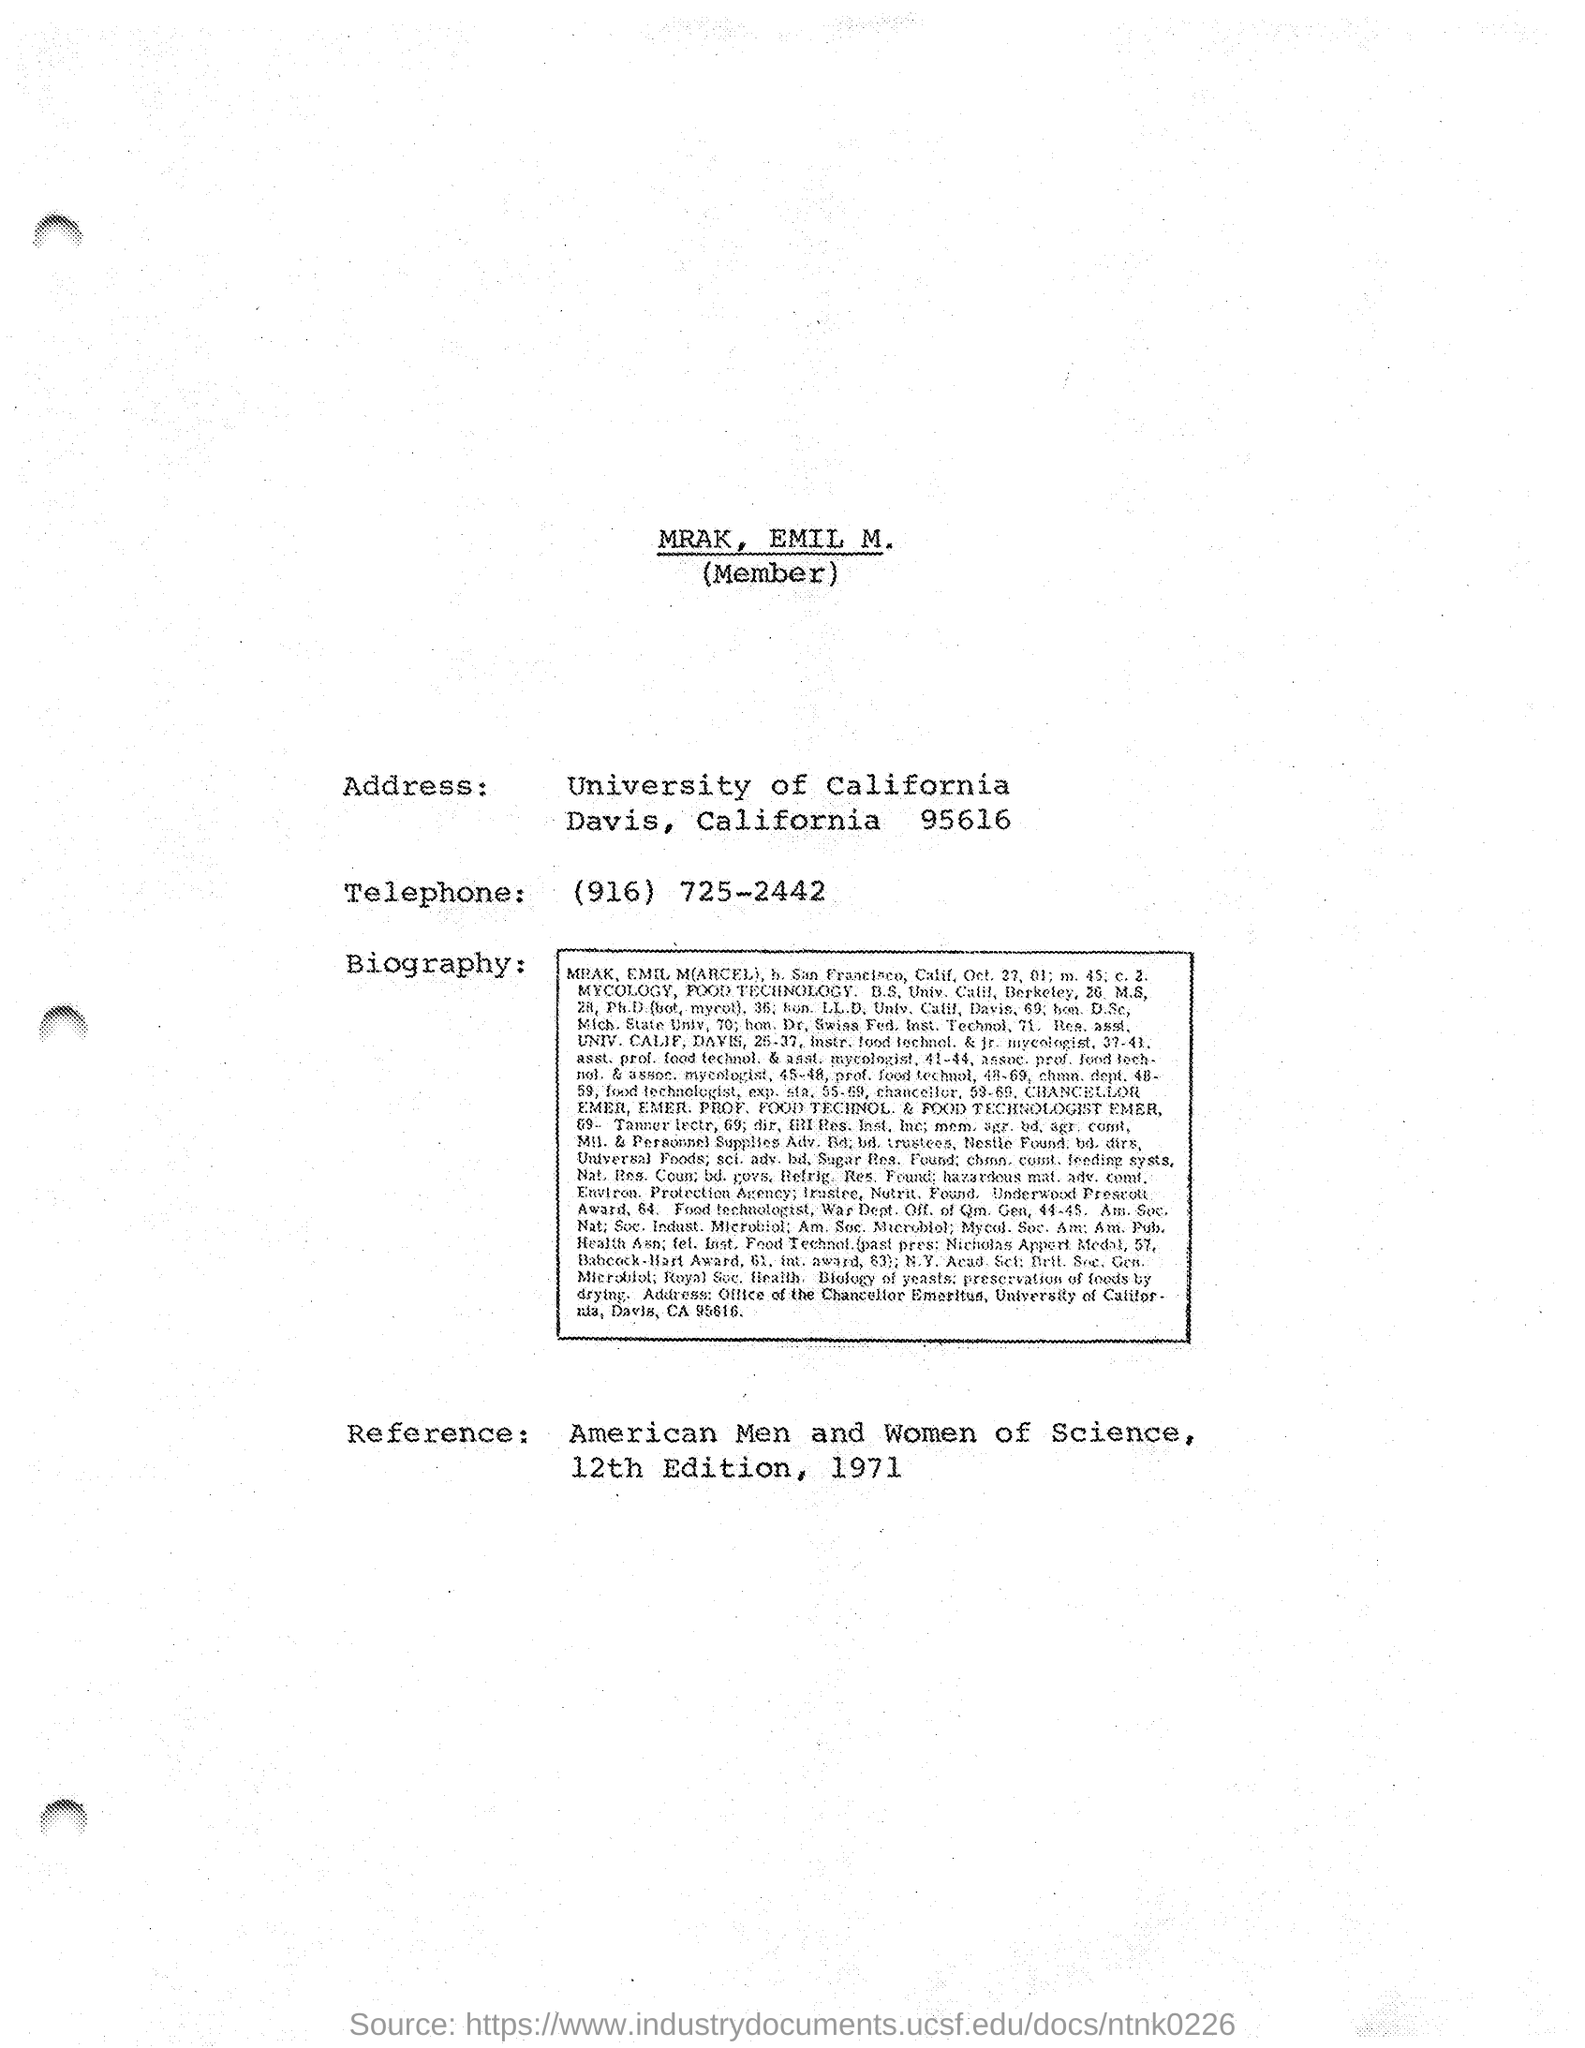What is the telephone number mentioned ?
Your answer should be very brief. (916) 725-2442. What is the name of the  university ?
Offer a terse response. University of california. What is the edition no mentioned in the reference
Offer a very short reply. 12th. 